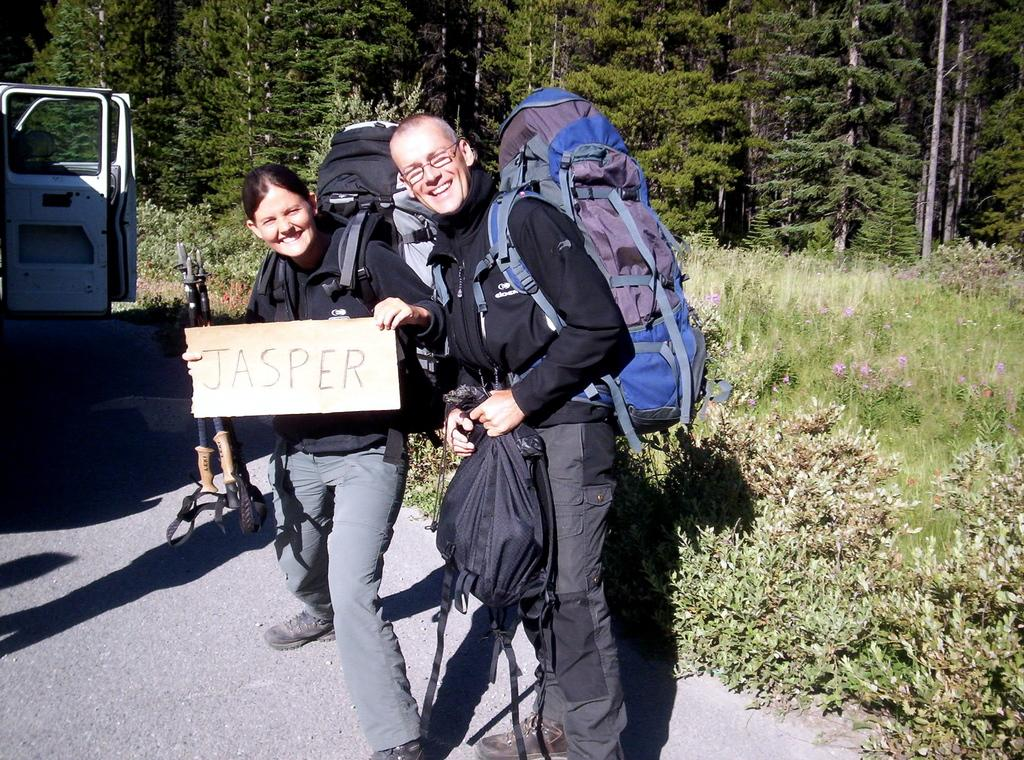How many people are in the image? There are two persons standing and smiling in the image. What are the persons wearing? The persons are wearing bags. What are the persons holding in the image? The persons are holding objects. What can be seen on the road in the image? There are vehicles visible on the road in the image. What type of vegetation is visible in the background of the image? There are trees and plants in the background of the image. How many fingers can be seen on the hand of the person in the image? There is no hand or finger visible in the image; the persons are wearing bags that cover their hands. 